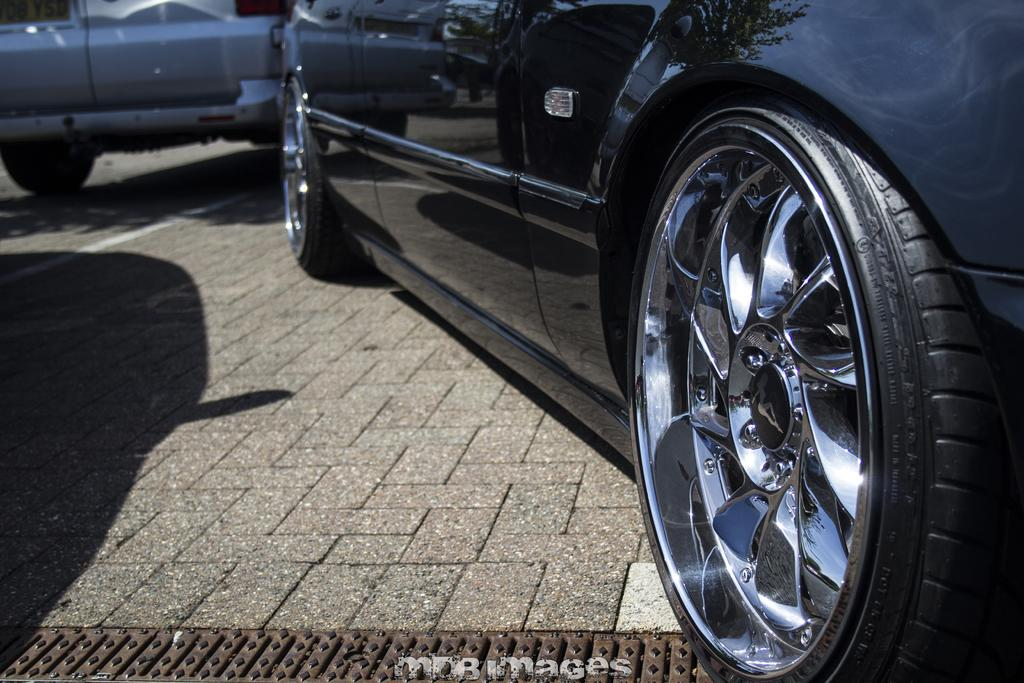What is the main subject of the image? The main subject of the image is a car. Where is the car located in the image? The car is in the center of the image. What color is the car? The car is black in color. What type of kettle is visible in the image? There is no kettle present in the image; it features a black car in the center. Can you tell me which person in the image is the achiever? There are no people present in the image, so it is not possible to determine who the achiever might be. 